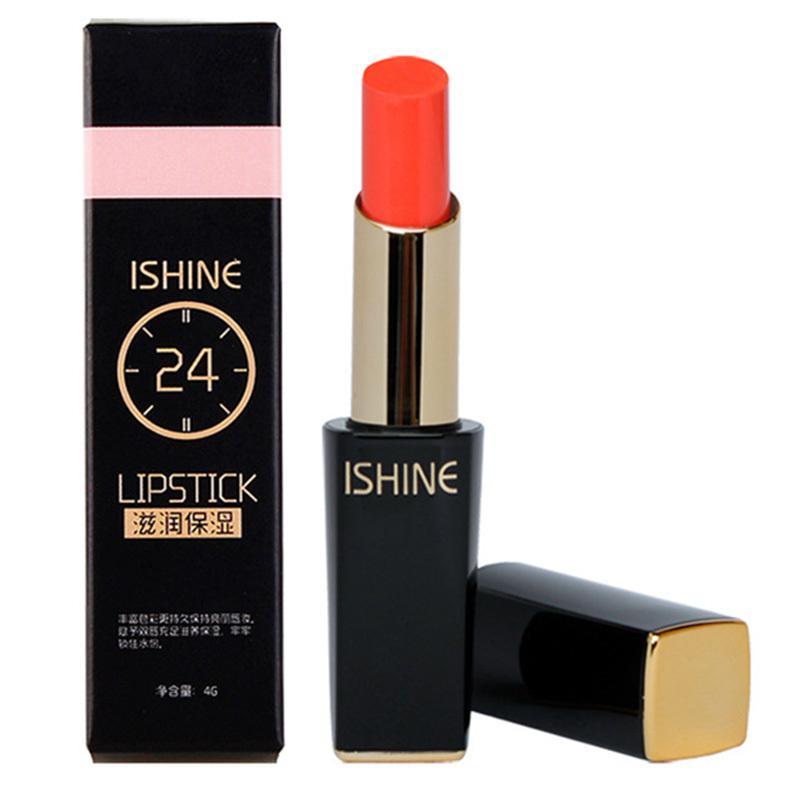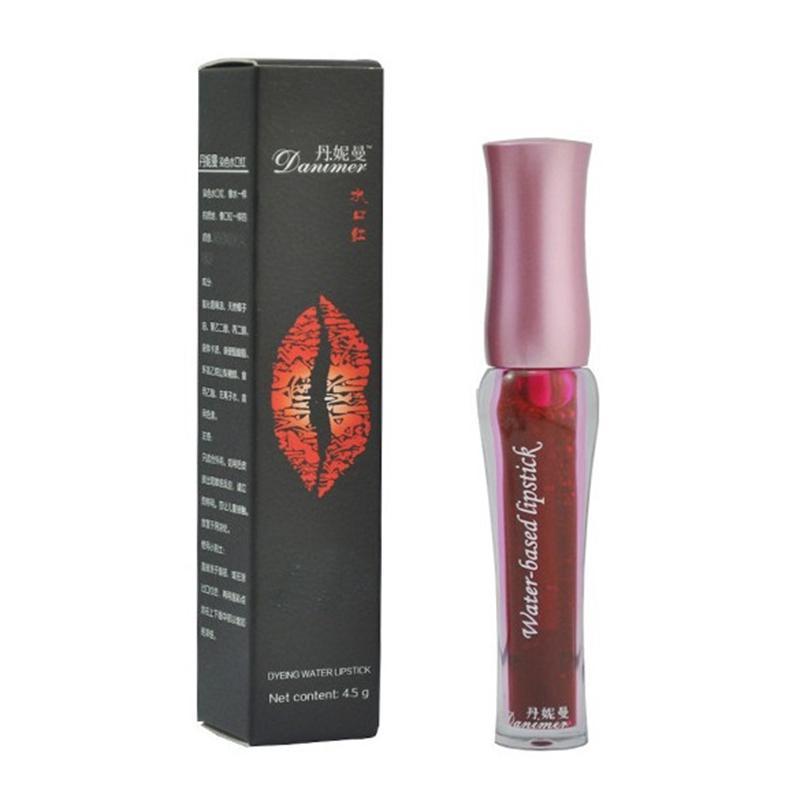The first image is the image on the left, the second image is the image on the right. For the images shown, is this caption "There are exactly three items in the image on the left." true? Answer yes or no. Yes. 